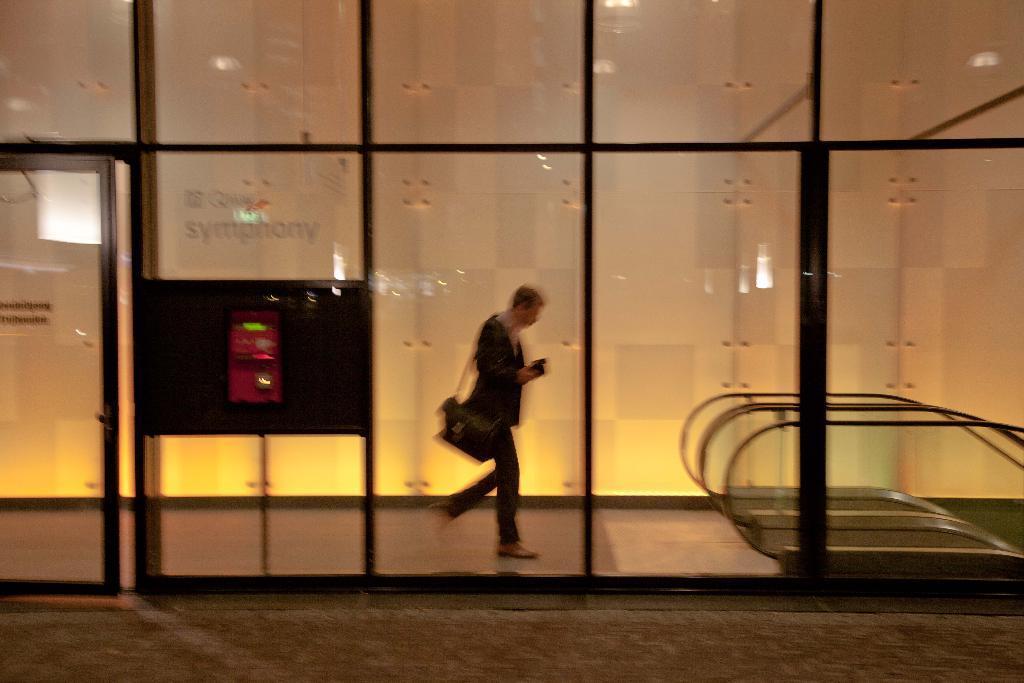In one or two sentences, can you explain what this image depicts? In this picture there is a person holding the object and he is walking. In the foreground there is a glass wall and there is an object and there is text on the wall. Behind the wall there are escalators and there are reflections of light on the wall. At the bottom there is a floor. 